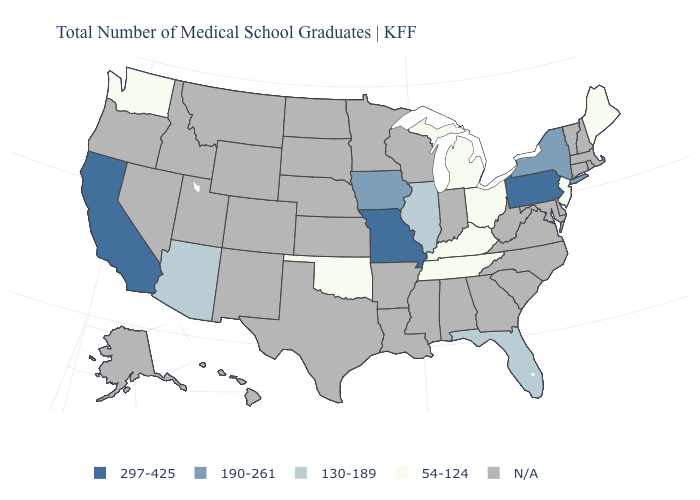Does Maine have the lowest value in the Northeast?
Short answer required. Yes. What is the value of Washington?
Keep it brief. 54-124. What is the value of South Dakota?
Be succinct. N/A. What is the value of Nevada?
Write a very short answer. N/A. What is the value of Montana?
Write a very short answer. N/A. Is the legend a continuous bar?
Concise answer only. No. Name the states that have a value in the range 130-189?
Answer briefly. Arizona, Florida, Illinois. Does Ohio have the highest value in the USA?
Keep it brief. No. Does the first symbol in the legend represent the smallest category?
Be succinct. No. Name the states that have a value in the range 297-425?
Short answer required. California, Missouri, Pennsylvania. Which states have the highest value in the USA?
Answer briefly. California, Missouri, Pennsylvania. What is the value of New York?
Keep it brief. 190-261. Name the states that have a value in the range N/A?
Write a very short answer. Alabama, Alaska, Arkansas, Colorado, Connecticut, Delaware, Georgia, Hawaii, Idaho, Indiana, Kansas, Louisiana, Maryland, Massachusetts, Minnesota, Mississippi, Montana, Nebraska, Nevada, New Hampshire, New Mexico, North Carolina, North Dakota, Oregon, Rhode Island, South Carolina, South Dakota, Texas, Utah, Vermont, Virginia, West Virginia, Wisconsin, Wyoming. 